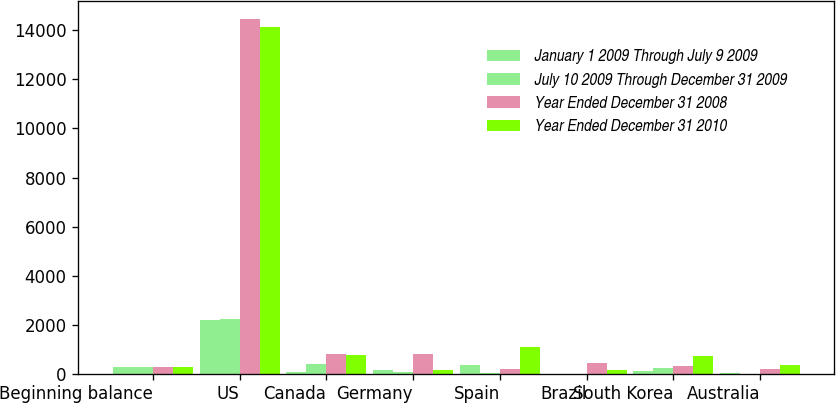Convert chart. <chart><loc_0><loc_0><loc_500><loc_500><stacked_bar_chart><ecel><fcel>Beginning balance<fcel>US<fcel>Canada<fcel>Germany<fcel>Spain<fcel>Brazil<fcel>South Korea<fcel>Australia<nl><fcel>January 1 2009 Through July 9 2009<fcel>271<fcel>2196<fcel>63<fcel>139<fcel>378<fcel>1<fcel>121<fcel>39<nl><fcel>July 10 2009 Through December 31 2009<fcel>271<fcel>2226<fcel>405<fcel>67<fcel>40<fcel>1<fcel>221<fcel>7<nl><fcel>Year Ended December 31 2008<fcel>271<fcel>14474<fcel>802<fcel>792<fcel>200<fcel>442<fcel>321<fcel>190<nl><fcel>Year Ended December 31 2010<fcel>271<fcel>14146<fcel>759<fcel>140<fcel>1109<fcel>135<fcel>724<fcel>340<nl></chart> 